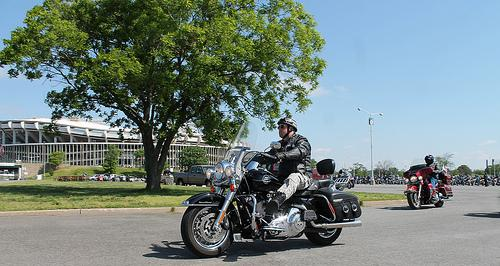Question: what color is the pavement?
Choices:
A. Black.
B. White.
C. Gray.
D. Yellow.
Answer with the letter. Answer: C Question: where are the other bikes?
Choices:
A. In the bike rack.
B. Background.
C. Next to the door.
D. By the stairwell.
Answer with the letter. Answer: B Question: what are the men riding?
Choices:
A. Motorcycles.
B. Unicycles.
C. Bicycles.
D. Horses.
Answer with the letter. Answer: A Question: who is on the bikes?
Choices:
A. Men.
B. Children.
C. School group.
D. University professors.
Answer with the letter. Answer: A Question: how many men are there?
Choices:
A. Three.
B. Two.
C. Four.
D. Five.
Answer with the letter. Answer: B 